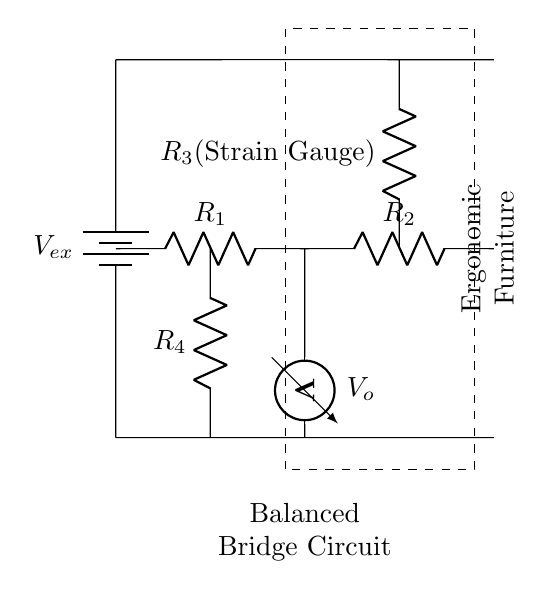What is the purpose of the strain gauge in this circuit? The strain gauge measures deformation or strain in the ergonomic furniture, and its resistance changes when subjected to stress. This change can then be detected as a change in voltage across the bridge circuit.
Answer: Measure deformation What is the value of the supplied voltage? The diagram indicates a battery but does not specify the voltage; typically, a common value like 5 volts is used in such applications.
Answer: 5 volts (assumed) How many resistors are present in the circuit? The circuit has a total of four resistors: R1, R2, R3 (the strain gauge), and R4.
Answer: Four resistors What component reflects the output voltage in the circuit? The voltmeter denotes the output voltage across the bridge circuit, providing a reading of the difference voltage due to the imbalance caused by the strain gauge.
Answer: Voltmeter Explain why the bridge circuit is balanced? A balanced bridge circuit occurs when the ratio of the resistances in one arm equals the ratio of the resistances in the other arm, resulting in zero voltage across the voltmeter. The precise values would depend on R1, R2, R3, and R4 but assume ideal conditions for a balance.
Answer: Zero voltage across voltmeter What does the dashed rectangle encompass in the diagram? The dashed rectangle encloses the entire balanced bridge circuit, indicating the component's collective function in measuring strain, thereby emphasizing their relation to ergonomic furniture.
Answer: Balanced Bridge Circuit 